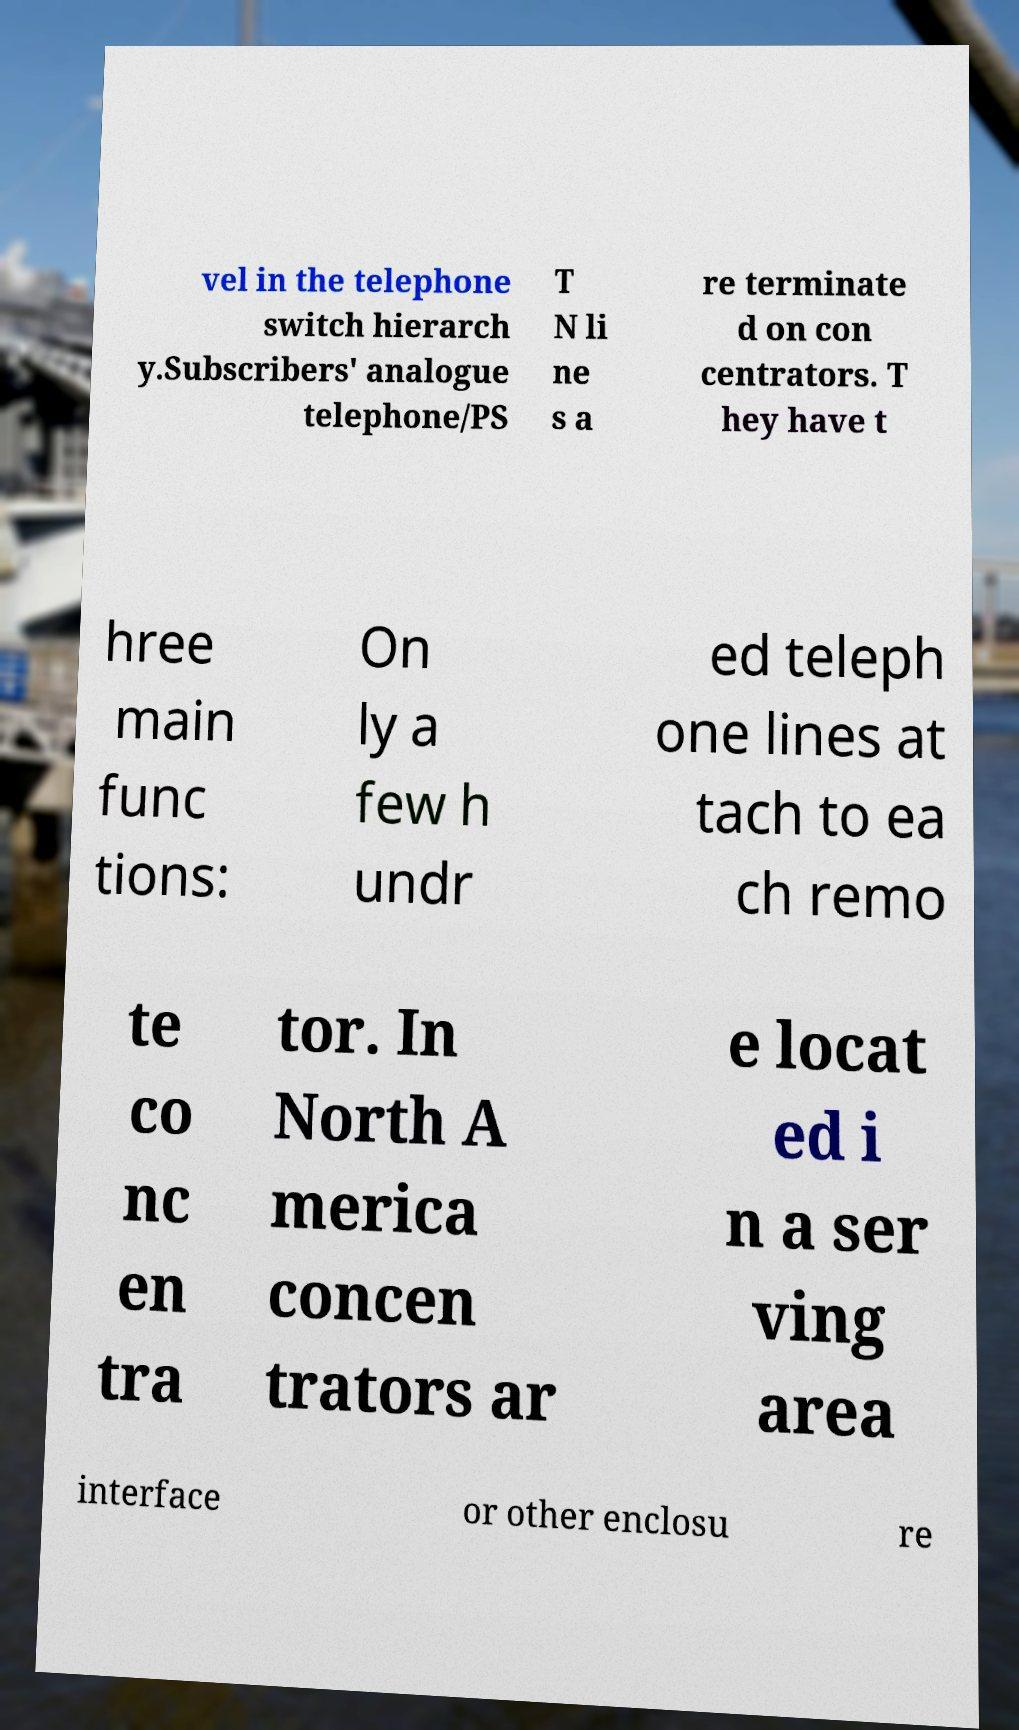What messages or text are displayed in this image? I need them in a readable, typed format. vel in the telephone switch hierarch y.Subscribers' analogue telephone/PS T N li ne s a re terminate d on con centrators. T hey have t hree main func tions: On ly a few h undr ed teleph one lines at tach to ea ch remo te co nc en tra tor. In North A merica concen trators ar e locat ed i n a ser ving area interface or other enclosu re 